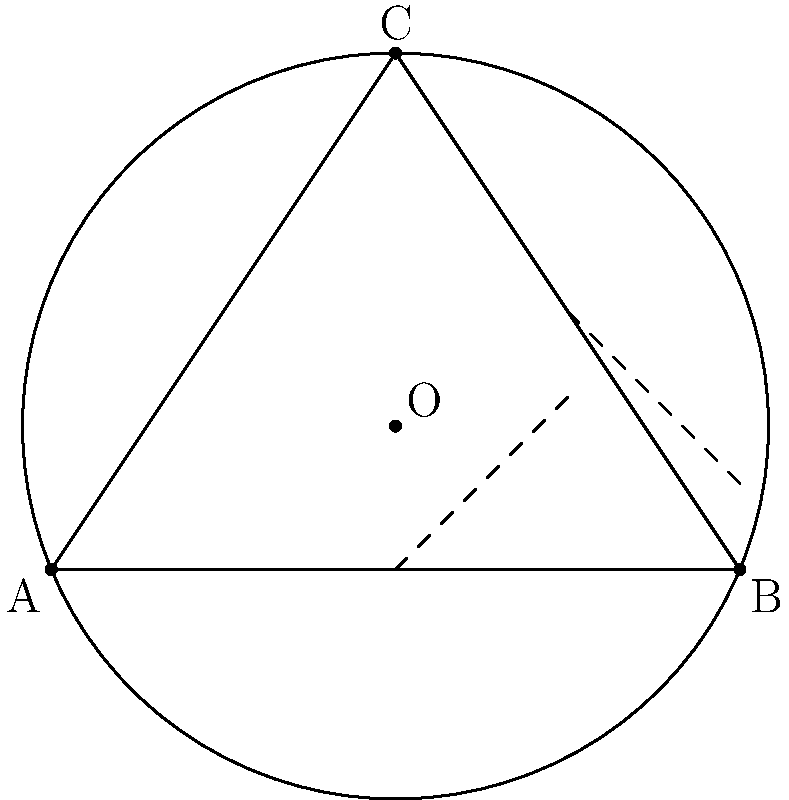In the Elizabethan era, architects often used geometric principles to design theatres. Consider three points A, B, and C on the circumference of a circular stage. How would you determine the center of this circular stage given these three points? To find the center of a circle given three points on its circumference, we can use the following steps:

1) First, we need to construct the perpendicular bisectors of any two chords formed by these points.

2) A perpendicular bisector of a chord always passes through the center of the circle.

3) To construct a perpendicular bisector:
   a) Find the midpoint of the chord.
   b) Draw a line perpendicular to the chord passing through this midpoint.

4) In our case, let's choose chords AB and BC:
   - Find midpoint M1 of AB
   - Find midpoint M2 of BC
   - Draw perpendicular lines through M1 and M2

5) The intersection point of these two perpendicular bisectors will be the center of the circle.

6) This point is equidistant from A, B, and C, satisfying the definition of a circle's center.

Mathematically, if we have the coordinates of A $(x_1, y_1)$, B $(x_2, y_2)$, and C $(x_3, y_3)$, we can find the center $(h, k)$ using the following equations:

$$ h = \frac{(x_1^2+y_1^2)(y_2-y_3) + (x_2^2+y_2^2)(y_3-y_1) + (x_3^2+y_3^2)(y_1-y_2)}{2(x_1(y_2-y_3) + x_2(y_3-y_1) + x_3(y_1-y_2))} $$

$$ k = \frac{(x_1^2+y_1^2)(x_3-x_2) + (x_2^2+y_2^2)(x_1-x_3) + (x_3^2+y_3^2)(x_2-x_1)}{2(x_1(y_2-y_3) + x_2(y_3-y_1) + x_3(y_1-y_2))} $$

This method, known as the circumcenter calculation, would have been invaluable to Elizabethan architects in designing perfectly circular stages.
Answer: Construct perpendicular bisectors of two chords; their intersection is the center. 